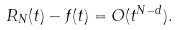<formula> <loc_0><loc_0><loc_500><loc_500>R _ { N } ( t ) - f ( t ) = O ( t ^ { N - d } ) .</formula> 